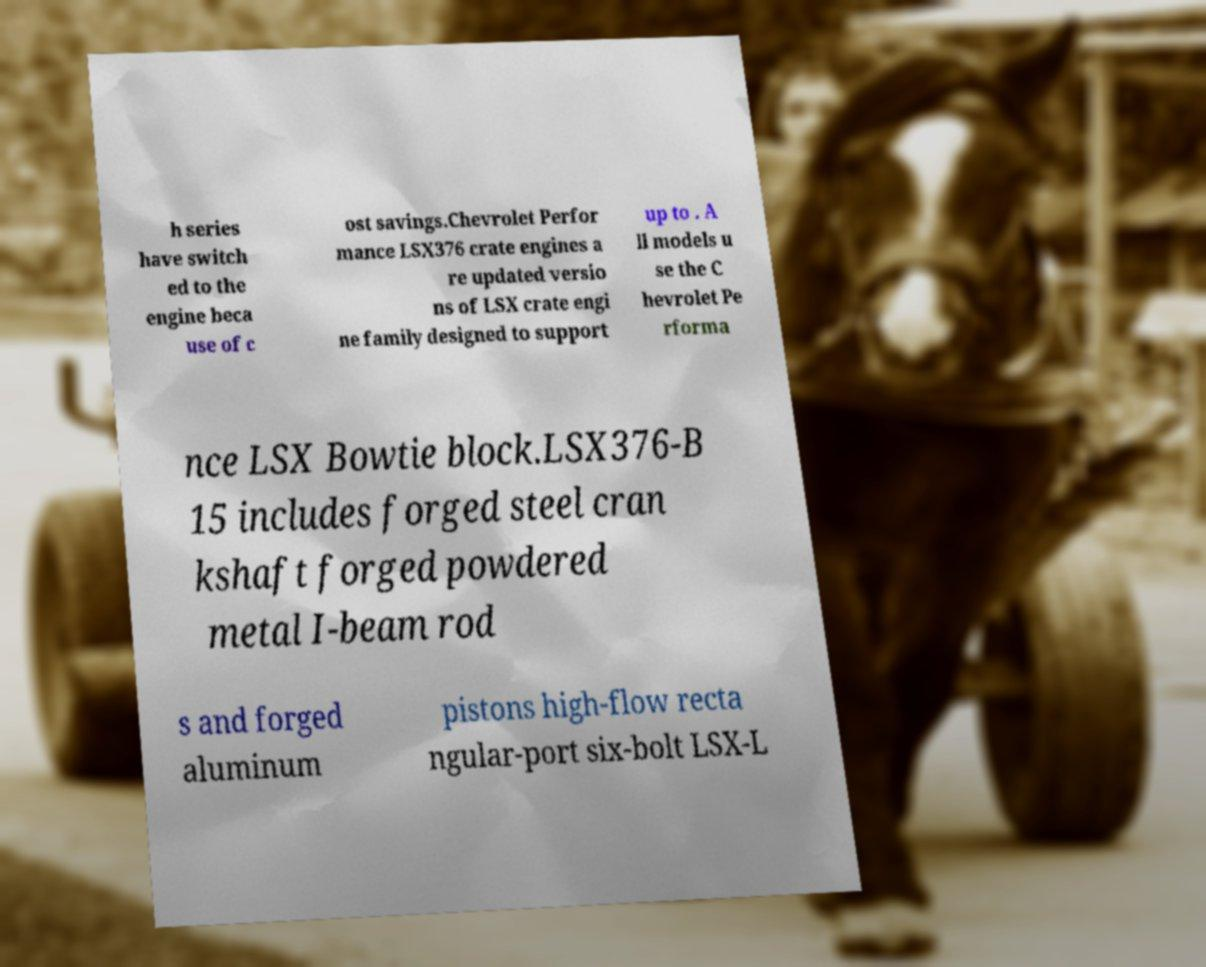There's text embedded in this image that I need extracted. Can you transcribe it verbatim? h series have switch ed to the engine beca use of c ost savings.Chevrolet Perfor mance LSX376 crate engines a re updated versio ns of LSX crate engi ne family designed to support up to . A ll models u se the C hevrolet Pe rforma nce LSX Bowtie block.LSX376-B 15 includes forged steel cran kshaft forged powdered metal I-beam rod s and forged aluminum pistons high-flow recta ngular-port six-bolt LSX-L 